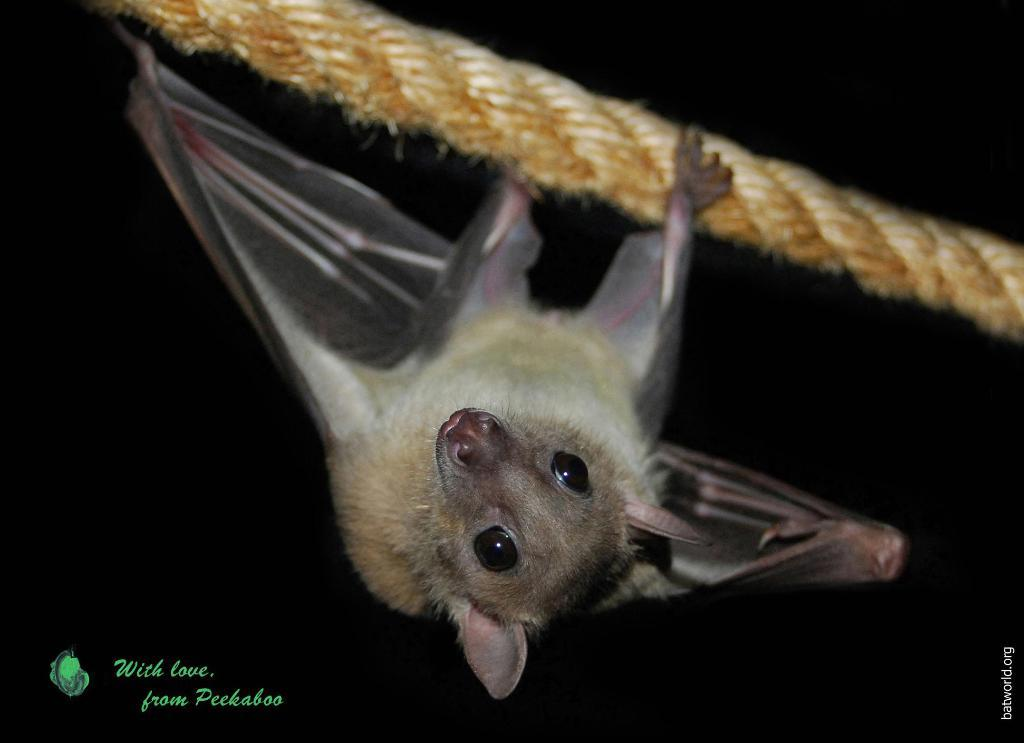What is the main subject in the foreground of the image? There is a bat in the foreground of the image. How is the bat positioned in the image? The bat is hanging upside down on a rope. What is the color of the background in the image? The background of the image is black. What type of crayon can be seen in the image? There is no crayon present in the image. How does the bat use its hearing to navigate in the image? The image does not provide information about the bat's hearing or navigation abilities. 